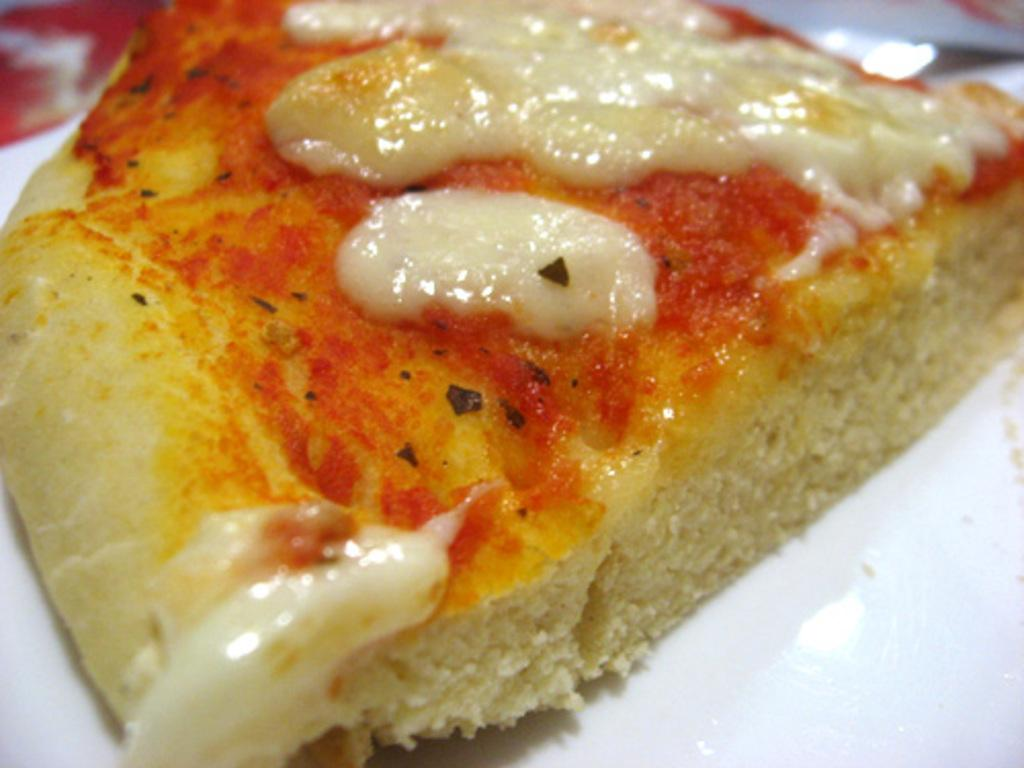What is the main subject of the image? There is a food item in the image. Can you describe the plate on which the food item is placed? The food item is on a white color plate. How many beetles can be seen crawling on the food item in the image? There are no beetles present in the image; it only features a food item on a white color plate. 